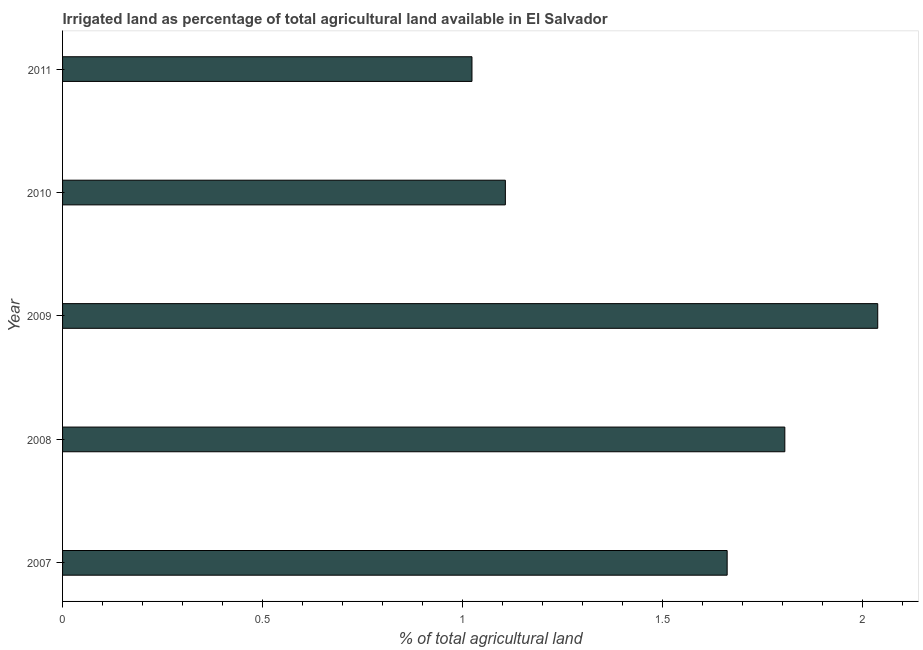Does the graph contain any zero values?
Make the answer very short. No. What is the title of the graph?
Ensure brevity in your answer.  Irrigated land as percentage of total agricultural land available in El Salvador. What is the label or title of the X-axis?
Provide a succinct answer. % of total agricultural land. What is the percentage of agricultural irrigated land in 2007?
Keep it short and to the point. 1.66. Across all years, what is the maximum percentage of agricultural irrigated land?
Ensure brevity in your answer.  2.04. Across all years, what is the minimum percentage of agricultural irrigated land?
Your answer should be compact. 1.02. In which year was the percentage of agricultural irrigated land maximum?
Provide a succinct answer. 2009. In which year was the percentage of agricultural irrigated land minimum?
Make the answer very short. 2011. What is the sum of the percentage of agricultural irrigated land?
Keep it short and to the point. 7.64. What is the difference between the percentage of agricultural irrigated land in 2010 and 2011?
Give a very brief answer. 0.08. What is the average percentage of agricultural irrigated land per year?
Keep it short and to the point. 1.53. What is the median percentage of agricultural irrigated land?
Provide a succinct answer. 1.66. Do a majority of the years between 2009 and 2010 (inclusive) have percentage of agricultural irrigated land greater than 1 %?
Provide a succinct answer. Yes. What is the ratio of the percentage of agricultural irrigated land in 2007 to that in 2011?
Your response must be concise. 1.62. Is the percentage of agricultural irrigated land in 2008 less than that in 2010?
Offer a terse response. No. What is the difference between the highest and the second highest percentage of agricultural irrigated land?
Make the answer very short. 0.23. Is the sum of the percentage of agricultural irrigated land in 2007 and 2009 greater than the maximum percentage of agricultural irrigated land across all years?
Provide a short and direct response. Yes. In how many years, is the percentage of agricultural irrigated land greater than the average percentage of agricultural irrigated land taken over all years?
Ensure brevity in your answer.  3. Are all the bars in the graph horizontal?
Your answer should be compact. Yes. How many years are there in the graph?
Offer a very short reply. 5. Are the values on the major ticks of X-axis written in scientific E-notation?
Ensure brevity in your answer.  No. What is the % of total agricultural land of 2007?
Provide a short and direct response. 1.66. What is the % of total agricultural land of 2008?
Provide a short and direct response. 1.81. What is the % of total agricultural land of 2009?
Your response must be concise. 2.04. What is the % of total agricultural land of 2010?
Offer a terse response. 1.11. What is the % of total agricultural land in 2011?
Your answer should be compact. 1.02. What is the difference between the % of total agricultural land in 2007 and 2008?
Provide a short and direct response. -0.14. What is the difference between the % of total agricultural land in 2007 and 2009?
Make the answer very short. -0.38. What is the difference between the % of total agricultural land in 2007 and 2010?
Offer a terse response. 0.55. What is the difference between the % of total agricultural land in 2007 and 2011?
Provide a succinct answer. 0.64. What is the difference between the % of total agricultural land in 2008 and 2009?
Ensure brevity in your answer.  -0.23. What is the difference between the % of total agricultural land in 2008 and 2010?
Your answer should be compact. 0.7. What is the difference between the % of total agricultural land in 2008 and 2011?
Provide a short and direct response. 0.78. What is the difference between the % of total agricultural land in 2009 and 2010?
Ensure brevity in your answer.  0.93. What is the difference between the % of total agricultural land in 2009 and 2011?
Your response must be concise. 1.01. What is the difference between the % of total agricultural land in 2010 and 2011?
Offer a terse response. 0.08. What is the ratio of the % of total agricultural land in 2007 to that in 2009?
Your answer should be very brief. 0.81. What is the ratio of the % of total agricultural land in 2007 to that in 2010?
Ensure brevity in your answer.  1.5. What is the ratio of the % of total agricultural land in 2007 to that in 2011?
Offer a terse response. 1.62. What is the ratio of the % of total agricultural land in 2008 to that in 2009?
Offer a terse response. 0.89. What is the ratio of the % of total agricultural land in 2008 to that in 2010?
Offer a very short reply. 1.63. What is the ratio of the % of total agricultural land in 2008 to that in 2011?
Your response must be concise. 1.76. What is the ratio of the % of total agricultural land in 2009 to that in 2010?
Provide a short and direct response. 1.84. What is the ratio of the % of total agricultural land in 2009 to that in 2011?
Make the answer very short. 1.99. What is the ratio of the % of total agricultural land in 2010 to that in 2011?
Offer a very short reply. 1.08. 